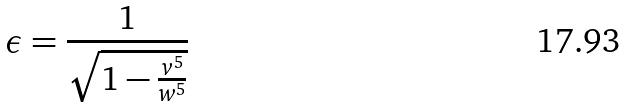<formula> <loc_0><loc_0><loc_500><loc_500>\epsilon = \frac { 1 } { \sqrt { 1 - \frac { v ^ { 5 } } { w ^ { 5 } } } }</formula> 